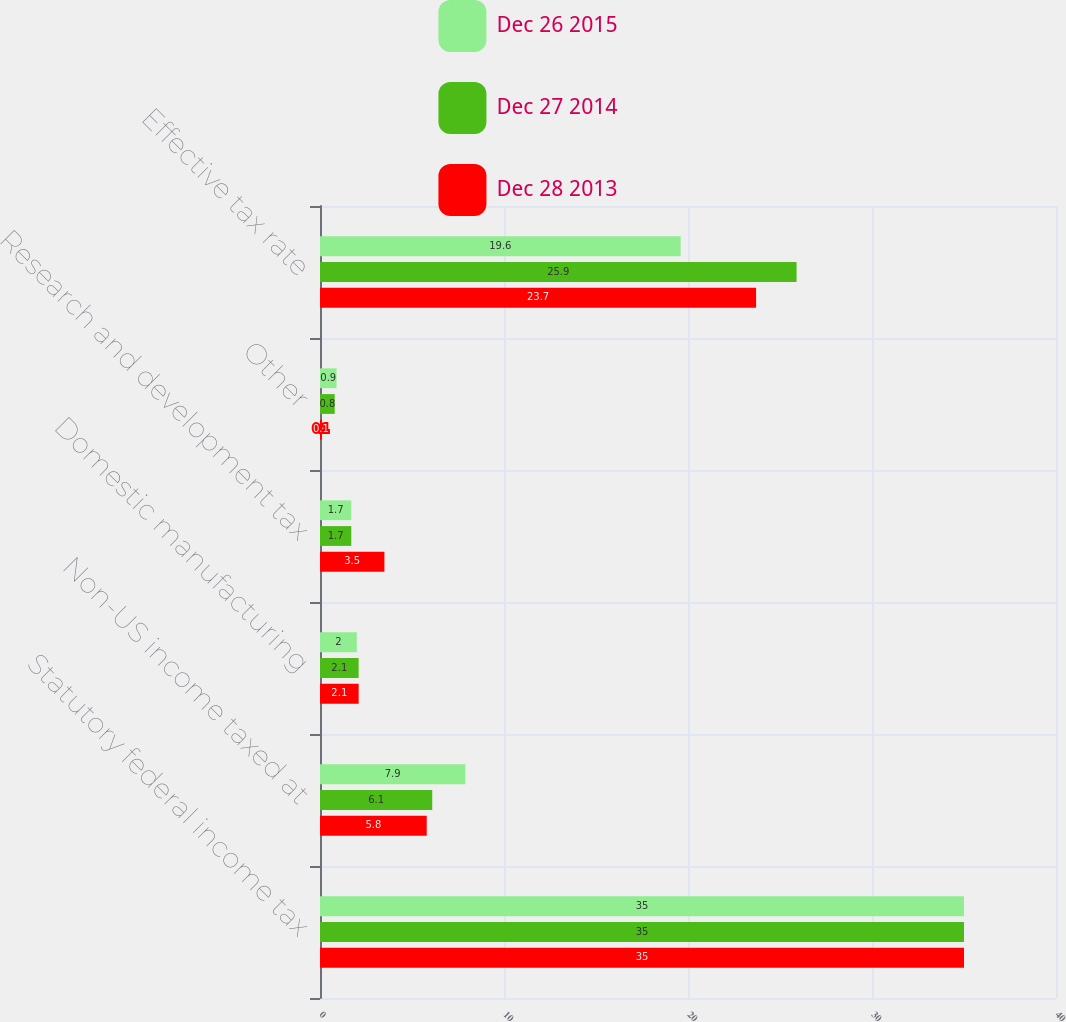Convert chart. <chart><loc_0><loc_0><loc_500><loc_500><stacked_bar_chart><ecel><fcel>Statutory federal income tax<fcel>Non-US income taxed at<fcel>Domestic manufacturing<fcel>Research and development tax<fcel>Other<fcel>Effective tax rate<nl><fcel>Dec 26 2015<fcel>35<fcel>7.9<fcel>2<fcel>1.7<fcel>0.9<fcel>19.6<nl><fcel>Dec 27 2014<fcel>35<fcel>6.1<fcel>2.1<fcel>1.7<fcel>0.8<fcel>25.9<nl><fcel>Dec 28 2013<fcel>35<fcel>5.8<fcel>2.1<fcel>3.5<fcel>0.1<fcel>23.7<nl></chart> 